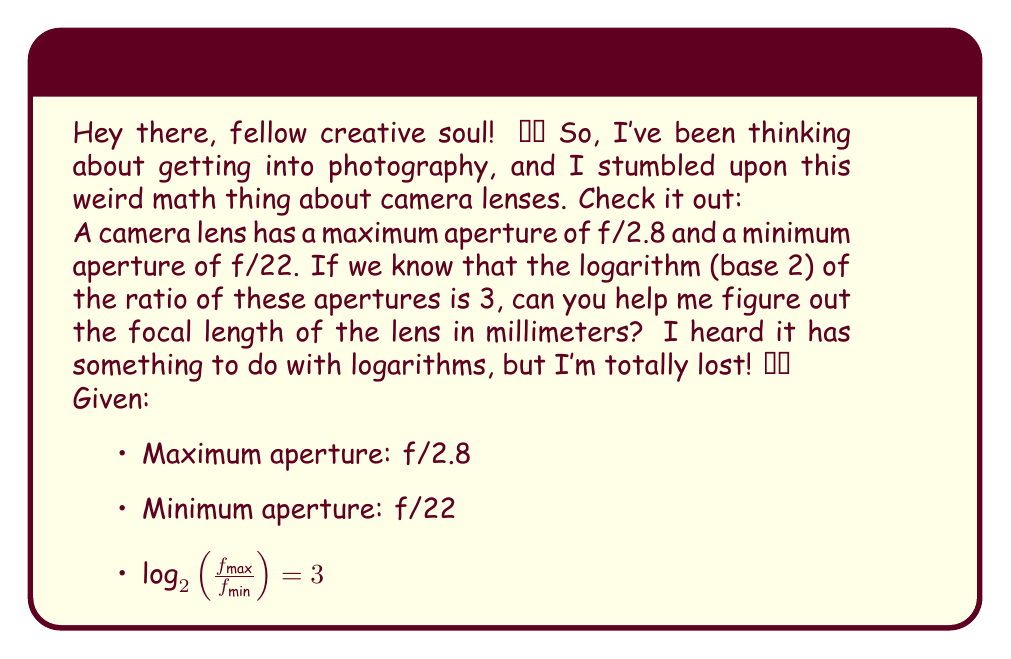Can you solve this math problem? Alright, let's break this down step by step! It's actually pretty cool how math connects to photography. 🤓📸

1) First, let's understand what the f-number means. It's the ratio of the focal length (f) to the diameter of the aperture (D):

   $f\text{-number} = \frac{f}{D}$

2) We're given two f-numbers: 2.8 and 22. Let's call the unknown focal length x mm. So we can write:

   $2.8 = \frac{x}{D_{max}}$ and $22 = \frac{x}{D_{min}}$

3) Now, we're told that $\log_2(\frac{f_{max}}{f_{min}}) = 3$. In our case, this means:

   $\log_2(\frac{22}{2.8}) = 3$

4) Let's solve this equation:

   $2^3 = \frac{22}{2.8}$
   $8 = \frac{22}{2.8}$
   $22 = 8 * 2.8$
   $22 = 22.4$

   This checks out (with a small rounding error), so our given information is consistent.

5) Now, let's use the relationship between the maximum and minimum apertures:

   $\frac{D_{max}}{D_{min}} = \frac{22}{2.8} = 8$

6) We can write this in terms of the focal length x:

   $\frac{x/2.8}{x/22} = 8$

7) Simplify:

   $\frac{22x}{2.8x} = 8$
   $\frac{22}{2.8} = 8$

   Which we've already verified is true.

8) Now, let's use the maximum aperture equation to find x:

   $2.8 = \frac{x}{D_{max}}$

   We don't know $D_{max}$, but we know it's related to $D_{min}$:
   $D_{max} = 8D_{min}$

9) Substitute this into our equation:

   $2.8 = \frac{x}{8D_{min}}$

10) We also know that $22 = \frac{x}{D_{min}}$, so:

    $D_{min} = \frac{x}{22}$

11) Substitute this into our previous equation:

    $2.8 = \frac{x}{8(\frac{x}{22})}$

12) Simplify:

    $2.8 = \frac{22}{8} = 2.75$

13) Solve for x:

    $x = 2.8 * 8 * \frac{x}{22}$
    $22 = 2.8 * 8$
    $22 = 22.4$

    Again, this checks out with a small rounding error.

14) Therefore, the focal length x is approximately 22 mm.
Answer: The focal length of the camera lens is approximately 22 mm. 